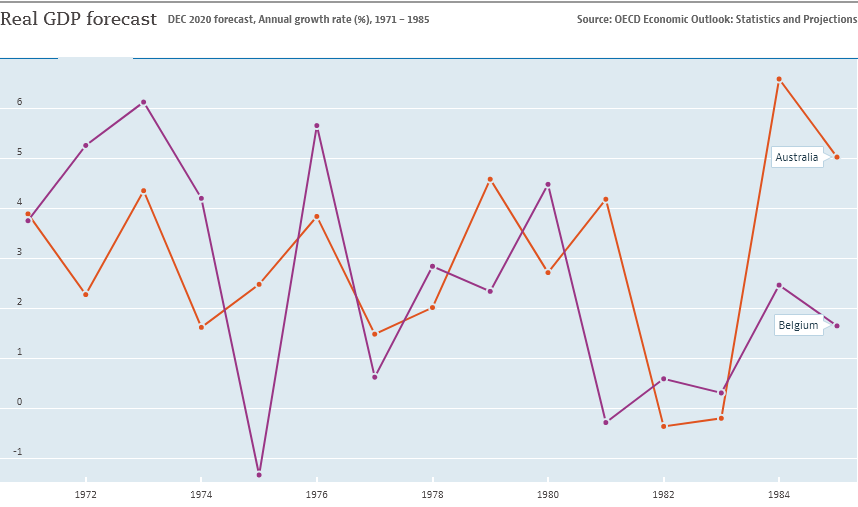Specify some key components in this picture. The red line in the chart represents Australia. I have data from 1 to... Is there any value below -1? 